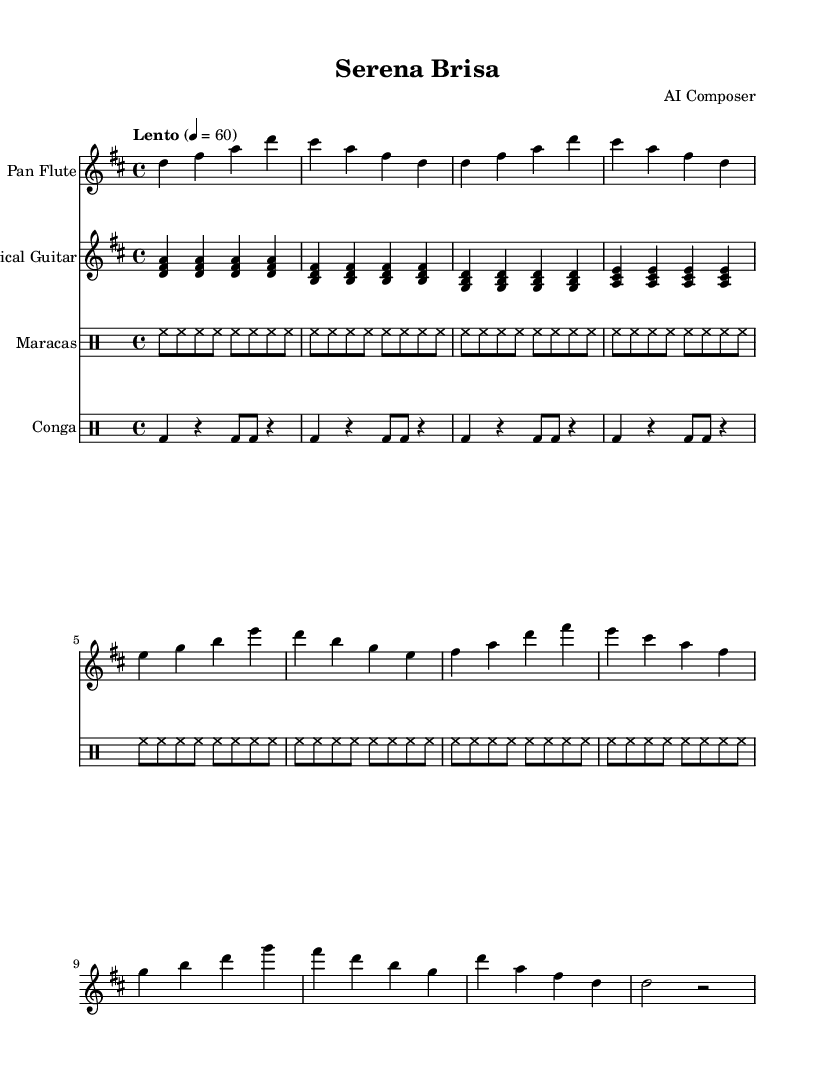What is the key signature of this music? The key signature is D major, which has two sharps (F# and C#). This can be determined by looking at the key signature indicated at the beginning of the piece.
Answer: D major What is the time signature of this music? The time signature is 4/4, which is indicated at the beginning of the staff. It means there are four beats in each measure, and the quarter note gets one beat.
Answer: 4/4 What is the tempo marking of the piece? The tempo marking indicates "Lento," which means slow, and the metronome marking of 60 beats per minute suggests a walking pace, or one beat per second. This information is given at the start of the score.
Answer: Lento How many instruments are featured in this piece? There are four instruments featured in this piece: Pan Flute, Classical Guitar, Maracas, and Conga. The instruments are explicitly mentioned within their respective staves in the score.
Answer: Four What instrument plays the melody in this piece? The melody is primarily played by the Pan Flute, which has the melodic line in the upper staff. Looking at the scored notes, the Pan Flute plays more distinctive and prominent notes compared to the other instruments.
Answer: Pan Flute What rhythmic pattern do the Maracas play? The Maracas are playing a consistent and repetitive rhythm of eight eighth notes. The notation shows a series of high-hat sounds, creating a steady background rhythm typical for Latin music.
Answer: Eight eighth notes What chord is primarily repeated by the Classical Guitar? The Classical Guitar primarily plays a series of D major chords throughout the piece, which can be observed from the chord arrangements seen in the score. These chords are visually formed by the combination of notes played together in the measures.
Answer: D major chord 